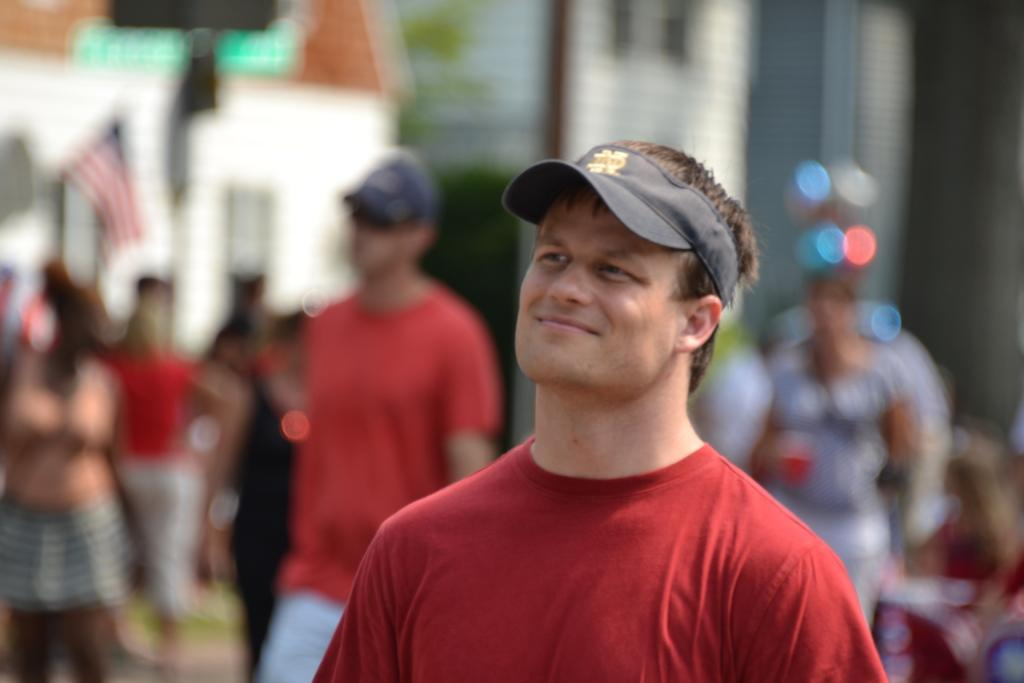Who is present in the image? There is a person in the image. What is the person wearing on their upper body? The person is wearing a red T-shirt. What type of headwear is the person wearing? The person is wearing a cap. What is the person's facial expression in the image? The person is smiling. How would you describe the background of the image? The background of the image is blurry. How many planes can be seen in the image? There are no planes present in the image. What number is written on the person's shirt in the image? The person's shirt does not have a number written on it; it is a red T-shirt. 